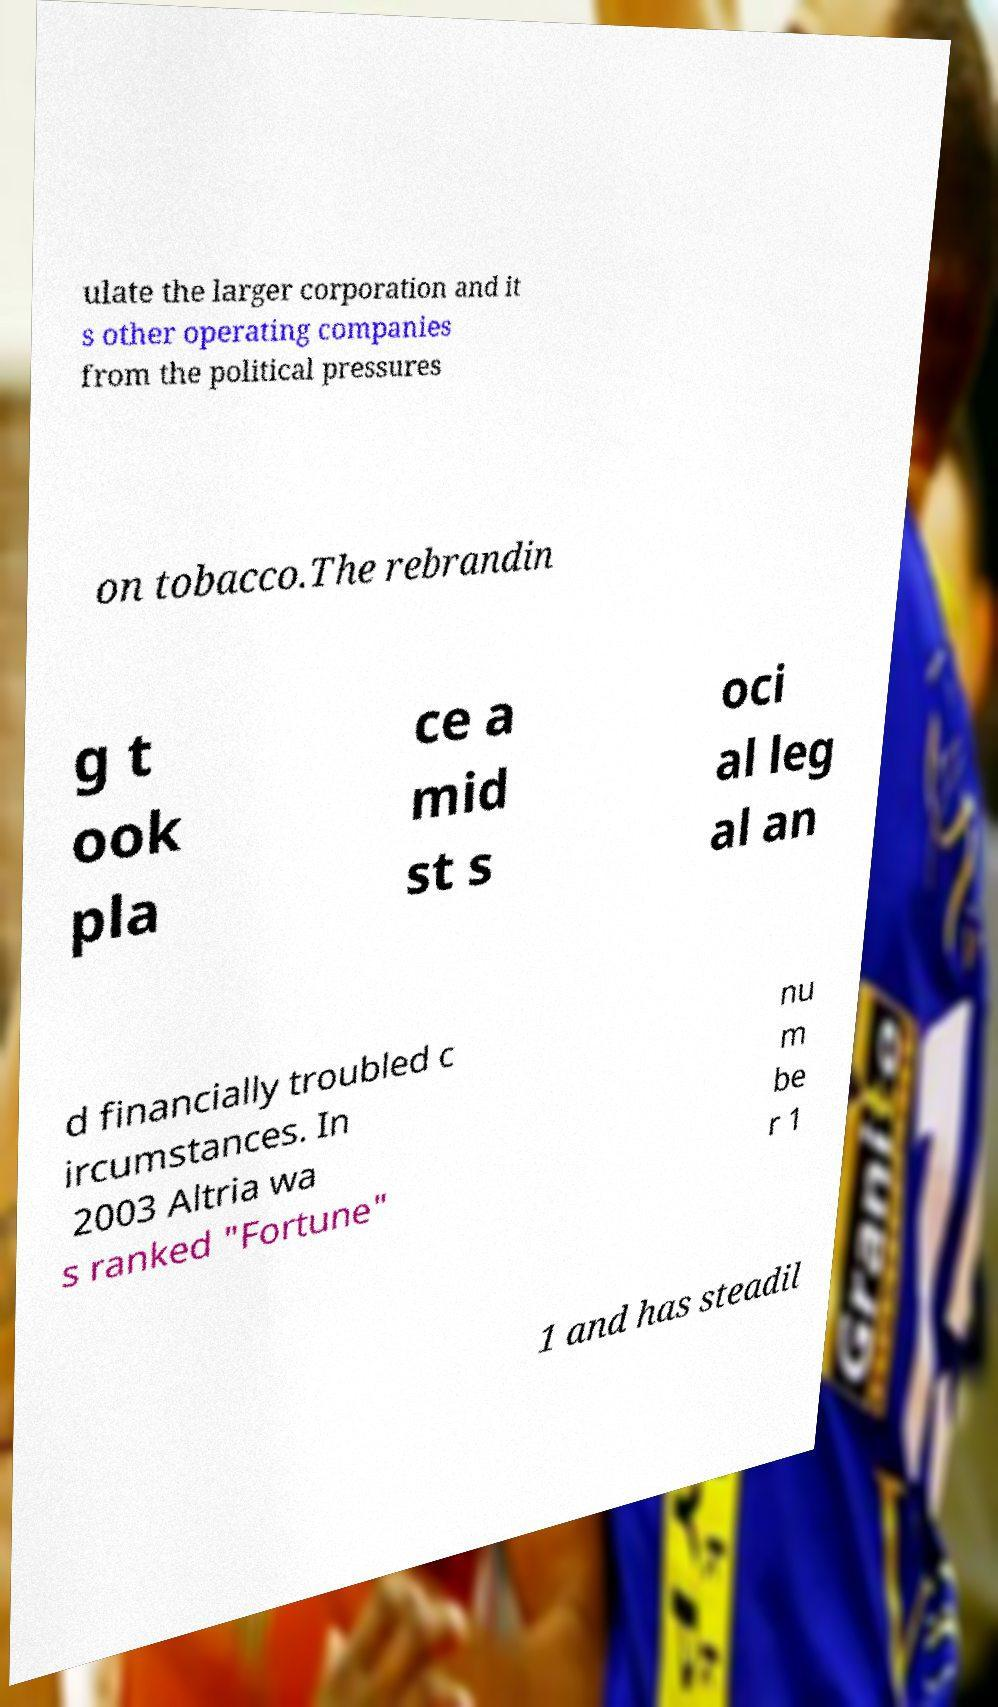Could you assist in decoding the text presented in this image and type it out clearly? ulate the larger corporation and it s other operating companies from the political pressures on tobacco.The rebrandin g t ook pla ce a mid st s oci al leg al an d financially troubled c ircumstances. In 2003 Altria wa s ranked "Fortune" nu m be r 1 1 and has steadil 